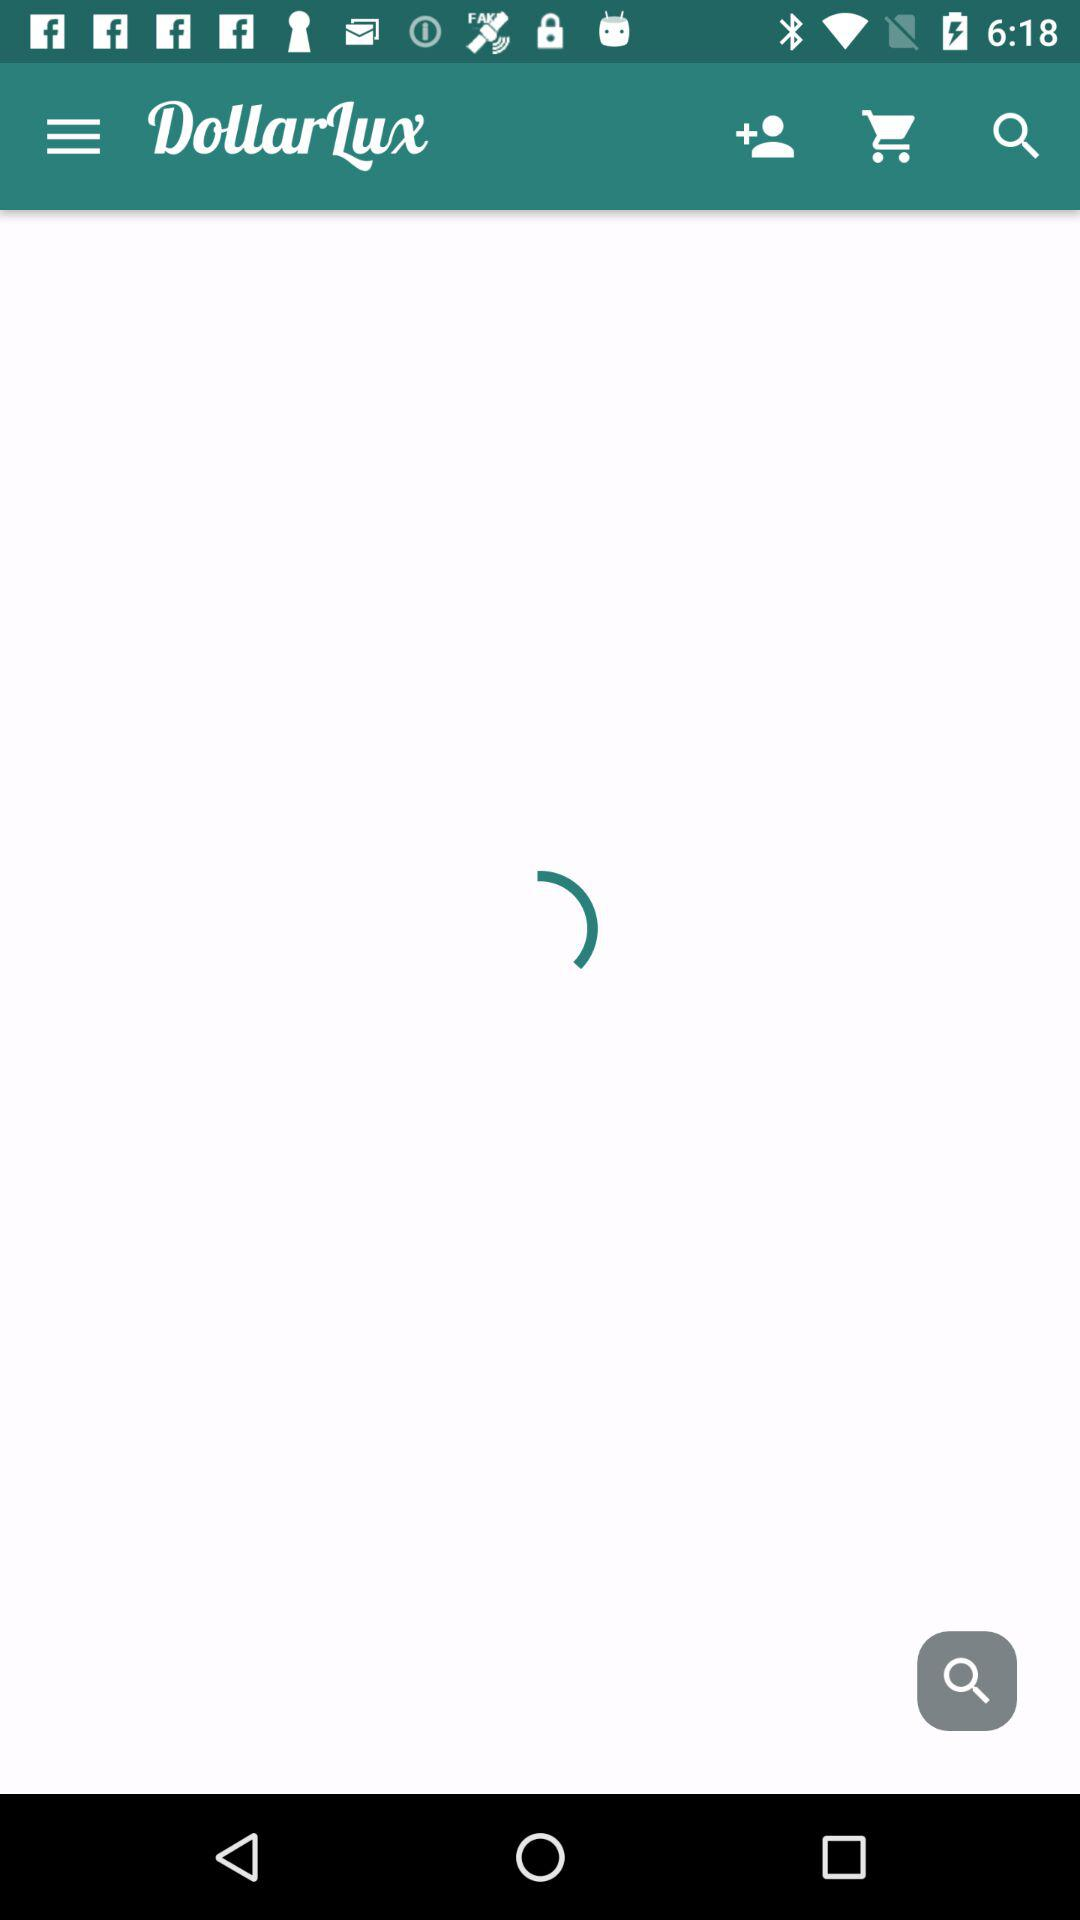What is the name of the application? The name of the application is "DollarLux". 